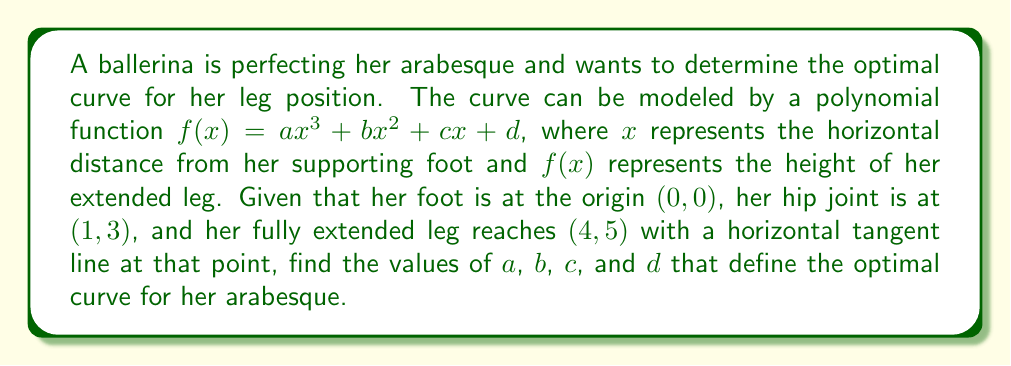Could you help me with this problem? Let's approach this step-by-step:

1) We have three conditions to satisfy:
   a) The curve passes through (0,0): $f(0) = 0$
   b) The curve passes through (1,3): $f(1) = 3$
   c) The curve passes through (4,5): $f(4) = 5$

2) We also know that the tangent line is horizontal at (4,5), which means:
   $f'(4) = 0$

3) Let's start with condition (a):
   $f(0) = a(0)^3 + b(0)^2 + c(0) + d = 0$
   This gives us: $d = 0$

4) Now, let's use conditions (b) and (c):
   $f(1) = a(1)^3 + b(1)^2 + c(1) + 0 = 3$
   $a + b + c = 3$ ... (equation 1)

   $f(4) = a(4)^3 + b(4)^2 + c(4) + 0 = 5$
   $64a + 16b + 4c = 5$ ... (equation 2)

5) For the horizontal tangent at x = 4:
   $f'(x) = 3ax^2 + 2bx + c$
   $f'(4) = 3a(4)^2 + 2b(4) + c = 0$
   $48a + 8b + c = 0$ ... (equation 3)

6) We now have a system of three equations with three unknowns:
   $a + b + c = 3$
   $64a + 16b + 4c = 5$
   $48a + 8b + c = 0$

7) Solving this system (you can use substitution or matrix methods):
   $a = -\frac{1}{16}$, $b = \frac{3}{8}$, $c = \frac{11}{4}$

Therefore, the optimal curve for the arabesque is defined by:
$$f(x) = -\frac{1}{16}x^3 + \frac{3}{8}x^2 + \frac{11}{4}x$$
Answer: $a = -\frac{1}{16}$, $b = \frac{3}{8}$, $c = \frac{11}{4}$, $d = 0$ 